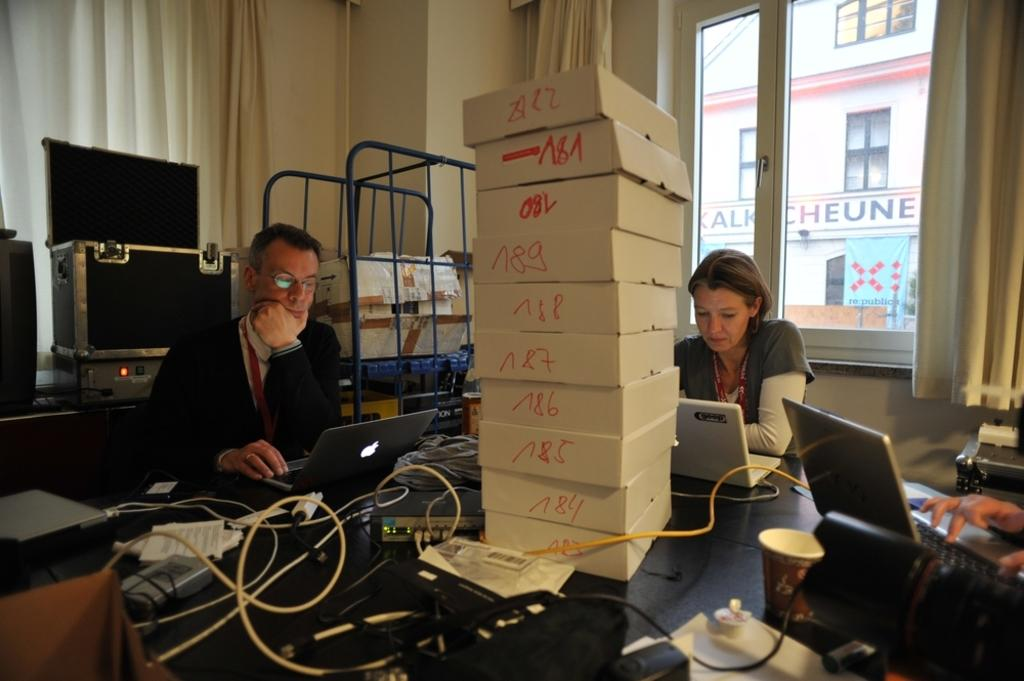Provide a one-sentence caption for the provided image. White boxes stacked on top of a table as people are working with top box being "A22". 